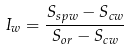<formula> <loc_0><loc_0><loc_500><loc_500>I _ { w } = \frac { S _ { s p w } - S _ { c w } } { S _ { o r } - S _ { c w } }</formula> 